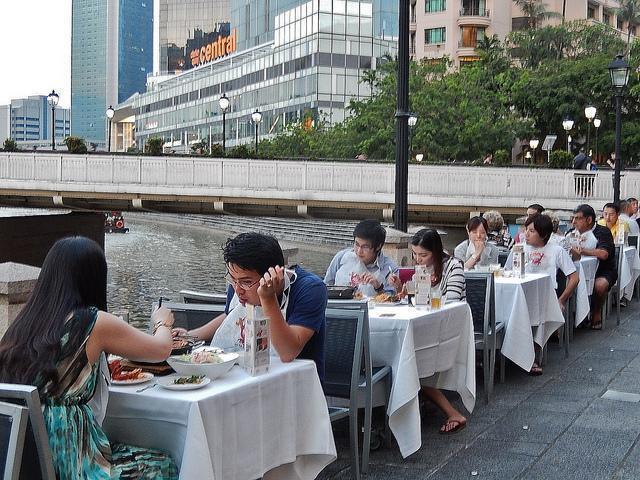What kind of meal are they having?
Pick the correct solution from the four options below to address the question.
Options: Steak, chicken, lobster, vegetarian. Lobster. 